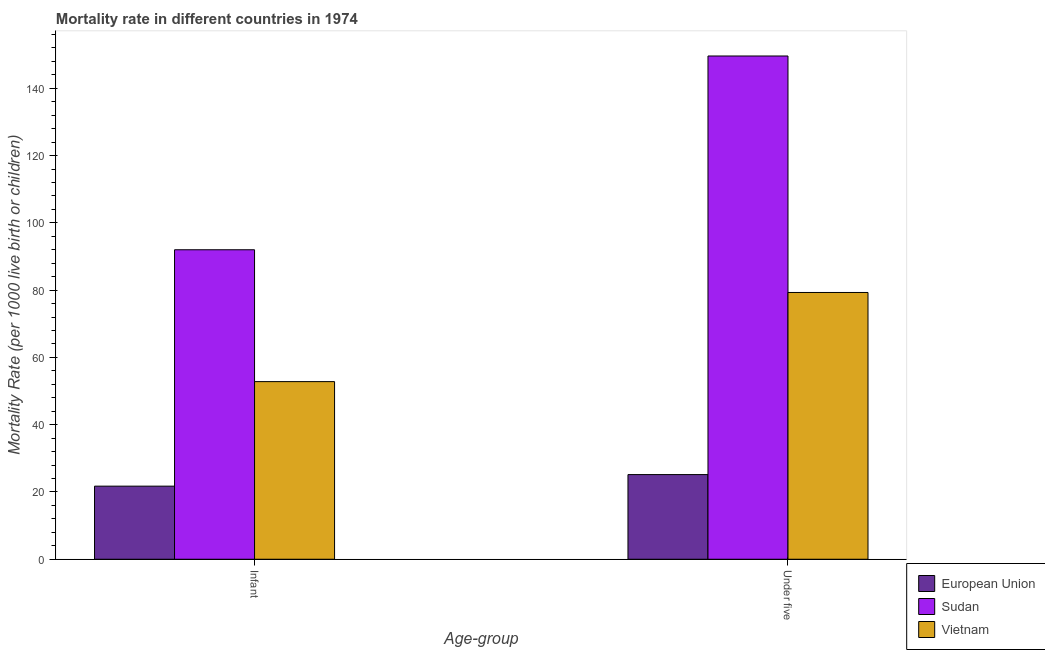How many different coloured bars are there?
Provide a succinct answer. 3. How many groups of bars are there?
Provide a succinct answer. 2. Are the number of bars per tick equal to the number of legend labels?
Offer a very short reply. Yes. Are the number of bars on each tick of the X-axis equal?
Your answer should be very brief. Yes. How many bars are there on the 2nd tick from the left?
Keep it short and to the point. 3. What is the label of the 1st group of bars from the left?
Offer a terse response. Infant. What is the under-5 mortality rate in Sudan?
Keep it short and to the point. 149.6. Across all countries, what is the maximum under-5 mortality rate?
Keep it short and to the point. 149.6. Across all countries, what is the minimum infant mortality rate?
Ensure brevity in your answer.  21.73. In which country was the under-5 mortality rate maximum?
Make the answer very short. Sudan. What is the total under-5 mortality rate in the graph?
Your answer should be very brief. 254.07. What is the difference between the infant mortality rate in Vietnam and that in Sudan?
Provide a short and direct response. -39.2. What is the difference between the under-5 mortality rate in Vietnam and the infant mortality rate in Sudan?
Provide a succinct answer. -12.7. What is the average under-5 mortality rate per country?
Offer a very short reply. 84.69. What is the difference between the under-5 mortality rate and infant mortality rate in Sudan?
Ensure brevity in your answer.  57.6. In how many countries, is the under-5 mortality rate greater than 132 ?
Your answer should be very brief. 1. What is the ratio of the under-5 mortality rate in Vietnam to that in European Union?
Offer a terse response. 3.15. What does the 3rd bar from the left in Under five represents?
Your response must be concise. Vietnam. How many countries are there in the graph?
Your response must be concise. 3. What is the difference between two consecutive major ticks on the Y-axis?
Ensure brevity in your answer.  20. Does the graph contain any zero values?
Offer a very short reply. No. Does the graph contain grids?
Your answer should be compact. No. How many legend labels are there?
Provide a succinct answer. 3. How are the legend labels stacked?
Offer a very short reply. Vertical. What is the title of the graph?
Keep it short and to the point. Mortality rate in different countries in 1974. Does "Switzerland" appear as one of the legend labels in the graph?
Your answer should be very brief. No. What is the label or title of the X-axis?
Your answer should be very brief. Age-group. What is the label or title of the Y-axis?
Your response must be concise. Mortality Rate (per 1000 live birth or children). What is the Mortality Rate (per 1000 live birth or children) in European Union in Infant?
Offer a very short reply. 21.73. What is the Mortality Rate (per 1000 live birth or children) in Sudan in Infant?
Ensure brevity in your answer.  92. What is the Mortality Rate (per 1000 live birth or children) of Vietnam in Infant?
Offer a terse response. 52.8. What is the Mortality Rate (per 1000 live birth or children) of European Union in Under five?
Your response must be concise. 25.17. What is the Mortality Rate (per 1000 live birth or children) of Sudan in Under five?
Offer a very short reply. 149.6. What is the Mortality Rate (per 1000 live birth or children) of Vietnam in Under five?
Your answer should be compact. 79.3. Across all Age-group, what is the maximum Mortality Rate (per 1000 live birth or children) in European Union?
Ensure brevity in your answer.  25.17. Across all Age-group, what is the maximum Mortality Rate (per 1000 live birth or children) of Sudan?
Your answer should be very brief. 149.6. Across all Age-group, what is the maximum Mortality Rate (per 1000 live birth or children) in Vietnam?
Offer a very short reply. 79.3. Across all Age-group, what is the minimum Mortality Rate (per 1000 live birth or children) in European Union?
Offer a very short reply. 21.73. Across all Age-group, what is the minimum Mortality Rate (per 1000 live birth or children) in Sudan?
Ensure brevity in your answer.  92. Across all Age-group, what is the minimum Mortality Rate (per 1000 live birth or children) in Vietnam?
Give a very brief answer. 52.8. What is the total Mortality Rate (per 1000 live birth or children) in European Union in the graph?
Keep it short and to the point. 46.89. What is the total Mortality Rate (per 1000 live birth or children) of Sudan in the graph?
Provide a succinct answer. 241.6. What is the total Mortality Rate (per 1000 live birth or children) in Vietnam in the graph?
Give a very brief answer. 132.1. What is the difference between the Mortality Rate (per 1000 live birth or children) of European Union in Infant and that in Under five?
Offer a terse response. -3.44. What is the difference between the Mortality Rate (per 1000 live birth or children) in Sudan in Infant and that in Under five?
Provide a succinct answer. -57.6. What is the difference between the Mortality Rate (per 1000 live birth or children) of Vietnam in Infant and that in Under five?
Provide a succinct answer. -26.5. What is the difference between the Mortality Rate (per 1000 live birth or children) of European Union in Infant and the Mortality Rate (per 1000 live birth or children) of Sudan in Under five?
Your response must be concise. -127.87. What is the difference between the Mortality Rate (per 1000 live birth or children) in European Union in Infant and the Mortality Rate (per 1000 live birth or children) in Vietnam in Under five?
Provide a succinct answer. -57.57. What is the average Mortality Rate (per 1000 live birth or children) in European Union per Age-group?
Your response must be concise. 23.45. What is the average Mortality Rate (per 1000 live birth or children) in Sudan per Age-group?
Provide a succinct answer. 120.8. What is the average Mortality Rate (per 1000 live birth or children) of Vietnam per Age-group?
Provide a short and direct response. 66.05. What is the difference between the Mortality Rate (per 1000 live birth or children) of European Union and Mortality Rate (per 1000 live birth or children) of Sudan in Infant?
Make the answer very short. -70.27. What is the difference between the Mortality Rate (per 1000 live birth or children) in European Union and Mortality Rate (per 1000 live birth or children) in Vietnam in Infant?
Your answer should be very brief. -31.07. What is the difference between the Mortality Rate (per 1000 live birth or children) in Sudan and Mortality Rate (per 1000 live birth or children) in Vietnam in Infant?
Your response must be concise. 39.2. What is the difference between the Mortality Rate (per 1000 live birth or children) of European Union and Mortality Rate (per 1000 live birth or children) of Sudan in Under five?
Your answer should be compact. -124.43. What is the difference between the Mortality Rate (per 1000 live birth or children) of European Union and Mortality Rate (per 1000 live birth or children) of Vietnam in Under five?
Ensure brevity in your answer.  -54.13. What is the difference between the Mortality Rate (per 1000 live birth or children) of Sudan and Mortality Rate (per 1000 live birth or children) of Vietnam in Under five?
Ensure brevity in your answer.  70.3. What is the ratio of the Mortality Rate (per 1000 live birth or children) of European Union in Infant to that in Under five?
Your answer should be very brief. 0.86. What is the ratio of the Mortality Rate (per 1000 live birth or children) in Sudan in Infant to that in Under five?
Provide a succinct answer. 0.61. What is the ratio of the Mortality Rate (per 1000 live birth or children) of Vietnam in Infant to that in Under five?
Ensure brevity in your answer.  0.67. What is the difference between the highest and the second highest Mortality Rate (per 1000 live birth or children) in European Union?
Offer a very short reply. 3.44. What is the difference between the highest and the second highest Mortality Rate (per 1000 live birth or children) in Sudan?
Keep it short and to the point. 57.6. What is the difference between the highest and the second highest Mortality Rate (per 1000 live birth or children) of Vietnam?
Offer a terse response. 26.5. What is the difference between the highest and the lowest Mortality Rate (per 1000 live birth or children) of European Union?
Your response must be concise. 3.44. What is the difference between the highest and the lowest Mortality Rate (per 1000 live birth or children) in Sudan?
Offer a terse response. 57.6. What is the difference between the highest and the lowest Mortality Rate (per 1000 live birth or children) of Vietnam?
Provide a succinct answer. 26.5. 